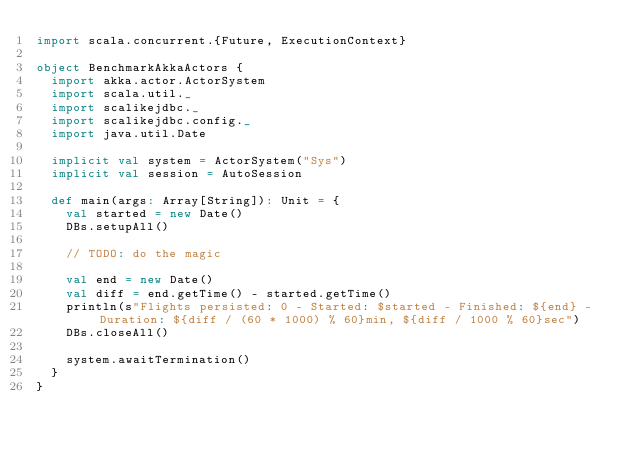<code> <loc_0><loc_0><loc_500><loc_500><_Scala_>import scala.concurrent.{Future, ExecutionContext}

object BenchmarkAkkaActors {
  import akka.actor.ActorSystem
  import scala.util._
  import scalikejdbc._
  import scalikejdbc.config._
  import java.util.Date

  implicit val system = ActorSystem("Sys")
  implicit val session = AutoSession

  def main(args: Array[String]): Unit = {
    val started = new Date()
    DBs.setupAll()

    // TODO: do the magic

    val end = new Date()
    val diff = end.getTime() - started.getTime()
    println(s"Flights persisted: 0 - Started: $started - Finished: ${end} - Duration: ${diff / (60 * 1000) % 60}min, ${diff / 1000 % 60}sec")
    DBs.closeAll()
    
    system.awaitTermination()
  }
}
</code> 